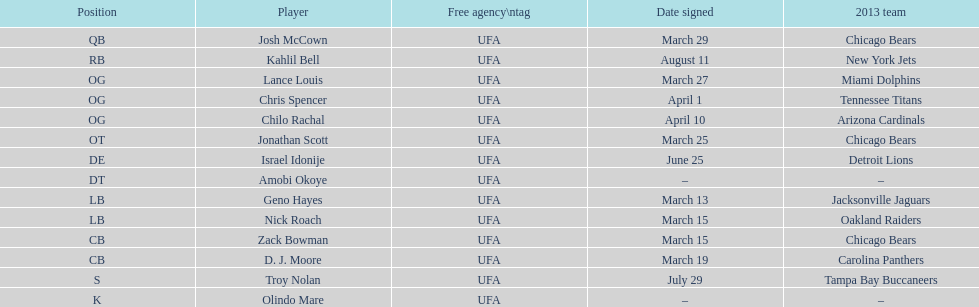The person's first name shares the same name as a nation. Israel Idonije. 